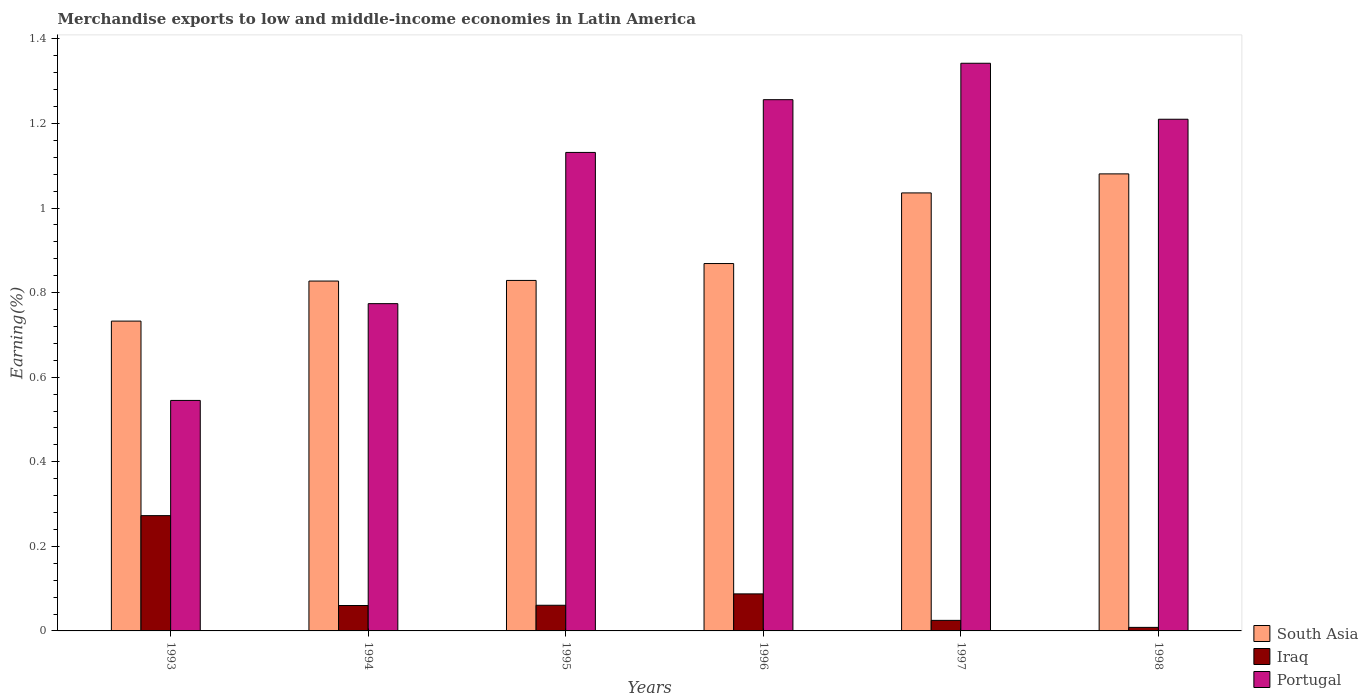How many bars are there on the 4th tick from the right?
Your answer should be very brief. 3. In how many cases, is the number of bars for a given year not equal to the number of legend labels?
Provide a short and direct response. 0. What is the percentage of amount earned from merchandise exports in Portugal in 1997?
Keep it short and to the point. 1.34. Across all years, what is the maximum percentage of amount earned from merchandise exports in Portugal?
Your response must be concise. 1.34. Across all years, what is the minimum percentage of amount earned from merchandise exports in South Asia?
Your answer should be very brief. 0.73. In which year was the percentage of amount earned from merchandise exports in Portugal minimum?
Your answer should be very brief. 1993. What is the total percentage of amount earned from merchandise exports in Portugal in the graph?
Offer a terse response. 6.26. What is the difference between the percentage of amount earned from merchandise exports in Portugal in 1994 and that in 1997?
Your answer should be compact. -0.57. What is the difference between the percentage of amount earned from merchandise exports in Iraq in 1993 and the percentage of amount earned from merchandise exports in South Asia in 1998?
Your answer should be very brief. -0.81. What is the average percentage of amount earned from merchandise exports in Iraq per year?
Your response must be concise. 0.09. In the year 1997, what is the difference between the percentage of amount earned from merchandise exports in Portugal and percentage of amount earned from merchandise exports in South Asia?
Make the answer very short. 0.31. What is the ratio of the percentage of amount earned from merchandise exports in South Asia in 1993 to that in 1995?
Your answer should be compact. 0.88. Is the percentage of amount earned from merchandise exports in South Asia in 1993 less than that in 1997?
Give a very brief answer. Yes. Is the difference between the percentage of amount earned from merchandise exports in Portugal in 1994 and 1997 greater than the difference between the percentage of amount earned from merchandise exports in South Asia in 1994 and 1997?
Make the answer very short. No. What is the difference between the highest and the second highest percentage of amount earned from merchandise exports in Iraq?
Make the answer very short. 0.19. What is the difference between the highest and the lowest percentage of amount earned from merchandise exports in Iraq?
Make the answer very short. 0.26. In how many years, is the percentage of amount earned from merchandise exports in Portugal greater than the average percentage of amount earned from merchandise exports in Portugal taken over all years?
Your answer should be very brief. 4. Is the sum of the percentage of amount earned from merchandise exports in Portugal in 1993 and 1998 greater than the maximum percentage of amount earned from merchandise exports in Iraq across all years?
Give a very brief answer. Yes. What does the 1st bar from the left in 1994 represents?
Your answer should be compact. South Asia. How many bars are there?
Your answer should be very brief. 18. Does the graph contain any zero values?
Your response must be concise. No. Does the graph contain grids?
Offer a very short reply. No. How many legend labels are there?
Provide a succinct answer. 3. What is the title of the graph?
Offer a terse response. Merchandise exports to low and middle-income economies in Latin America. Does "Sao Tome and Principe" appear as one of the legend labels in the graph?
Ensure brevity in your answer.  No. What is the label or title of the X-axis?
Ensure brevity in your answer.  Years. What is the label or title of the Y-axis?
Your answer should be very brief. Earning(%). What is the Earning(%) of South Asia in 1993?
Offer a very short reply. 0.73. What is the Earning(%) in Iraq in 1993?
Provide a succinct answer. 0.27. What is the Earning(%) in Portugal in 1993?
Keep it short and to the point. 0.55. What is the Earning(%) of South Asia in 1994?
Ensure brevity in your answer.  0.83. What is the Earning(%) of Iraq in 1994?
Make the answer very short. 0.06. What is the Earning(%) in Portugal in 1994?
Provide a succinct answer. 0.77. What is the Earning(%) of South Asia in 1995?
Offer a very short reply. 0.83. What is the Earning(%) in Iraq in 1995?
Make the answer very short. 0.06. What is the Earning(%) in Portugal in 1995?
Your answer should be very brief. 1.13. What is the Earning(%) of South Asia in 1996?
Give a very brief answer. 0.87. What is the Earning(%) in Iraq in 1996?
Make the answer very short. 0.09. What is the Earning(%) in Portugal in 1996?
Provide a short and direct response. 1.26. What is the Earning(%) in South Asia in 1997?
Keep it short and to the point. 1.04. What is the Earning(%) in Iraq in 1997?
Offer a very short reply. 0.02. What is the Earning(%) of Portugal in 1997?
Ensure brevity in your answer.  1.34. What is the Earning(%) of South Asia in 1998?
Offer a very short reply. 1.08. What is the Earning(%) of Iraq in 1998?
Your response must be concise. 0.01. What is the Earning(%) in Portugal in 1998?
Make the answer very short. 1.21. Across all years, what is the maximum Earning(%) of South Asia?
Provide a succinct answer. 1.08. Across all years, what is the maximum Earning(%) in Iraq?
Make the answer very short. 0.27. Across all years, what is the maximum Earning(%) in Portugal?
Provide a short and direct response. 1.34. Across all years, what is the minimum Earning(%) of South Asia?
Ensure brevity in your answer.  0.73. Across all years, what is the minimum Earning(%) in Iraq?
Offer a very short reply. 0.01. Across all years, what is the minimum Earning(%) in Portugal?
Keep it short and to the point. 0.55. What is the total Earning(%) of South Asia in the graph?
Your response must be concise. 5.37. What is the total Earning(%) in Iraq in the graph?
Offer a very short reply. 0.51. What is the total Earning(%) in Portugal in the graph?
Ensure brevity in your answer.  6.26. What is the difference between the Earning(%) in South Asia in 1993 and that in 1994?
Provide a succinct answer. -0.09. What is the difference between the Earning(%) in Iraq in 1993 and that in 1994?
Provide a succinct answer. 0.21. What is the difference between the Earning(%) in Portugal in 1993 and that in 1994?
Make the answer very short. -0.23. What is the difference between the Earning(%) of South Asia in 1993 and that in 1995?
Offer a terse response. -0.1. What is the difference between the Earning(%) of Iraq in 1993 and that in 1995?
Your response must be concise. 0.21. What is the difference between the Earning(%) in Portugal in 1993 and that in 1995?
Give a very brief answer. -0.59. What is the difference between the Earning(%) in South Asia in 1993 and that in 1996?
Give a very brief answer. -0.14. What is the difference between the Earning(%) of Iraq in 1993 and that in 1996?
Your answer should be very brief. 0.18. What is the difference between the Earning(%) of Portugal in 1993 and that in 1996?
Offer a very short reply. -0.71. What is the difference between the Earning(%) of South Asia in 1993 and that in 1997?
Make the answer very short. -0.3. What is the difference between the Earning(%) of Iraq in 1993 and that in 1997?
Your answer should be compact. 0.25. What is the difference between the Earning(%) in Portugal in 1993 and that in 1997?
Offer a terse response. -0.8. What is the difference between the Earning(%) of South Asia in 1993 and that in 1998?
Offer a very short reply. -0.35. What is the difference between the Earning(%) in Iraq in 1993 and that in 1998?
Your answer should be very brief. 0.26. What is the difference between the Earning(%) of Portugal in 1993 and that in 1998?
Keep it short and to the point. -0.66. What is the difference between the Earning(%) in South Asia in 1994 and that in 1995?
Provide a short and direct response. -0. What is the difference between the Earning(%) in Iraq in 1994 and that in 1995?
Provide a short and direct response. -0. What is the difference between the Earning(%) in Portugal in 1994 and that in 1995?
Offer a very short reply. -0.36. What is the difference between the Earning(%) in South Asia in 1994 and that in 1996?
Ensure brevity in your answer.  -0.04. What is the difference between the Earning(%) of Iraq in 1994 and that in 1996?
Make the answer very short. -0.03. What is the difference between the Earning(%) of Portugal in 1994 and that in 1996?
Your response must be concise. -0.48. What is the difference between the Earning(%) in South Asia in 1994 and that in 1997?
Provide a short and direct response. -0.21. What is the difference between the Earning(%) of Iraq in 1994 and that in 1997?
Provide a succinct answer. 0.04. What is the difference between the Earning(%) in Portugal in 1994 and that in 1997?
Offer a very short reply. -0.57. What is the difference between the Earning(%) in South Asia in 1994 and that in 1998?
Provide a short and direct response. -0.25. What is the difference between the Earning(%) in Iraq in 1994 and that in 1998?
Offer a terse response. 0.05. What is the difference between the Earning(%) of Portugal in 1994 and that in 1998?
Provide a short and direct response. -0.44. What is the difference between the Earning(%) in South Asia in 1995 and that in 1996?
Make the answer very short. -0.04. What is the difference between the Earning(%) in Iraq in 1995 and that in 1996?
Offer a very short reply. -0.03. What is the difference between the Earning(%) of Portugal in 1995 and that in 1996?
Ensure brevity in your answer.  -0.12. What is the difference between the Earning(%) of South Asia in 1995 and that in 1997?
Your answer should be very brief. -0.21. What is the difference between the Earning(%) in Iraq in 1995 and that in 1997?
Your answer should be very brief. 0.04. What is the difference between the Earning(%) of Portugal in 1995 and that in 1997?
Your response must be concise. -0.21. What is the difference between the Earning(%) of South Asia in 1995 and that in 1998?
Your answer should be very brief. -0.25. What is the difference between the Earning(%) in Iraq in 1995 and that in 1998?
Give a very brief answer. 0.05. What is the difference between the Earning(%) of Portugal in 1995 and that in 1998?
Ensure brevity in your answer.  -0.08. What is the difference between the Earning(%) in South Asia in 1996 and that in 1997?
Your response must be concise. -0.17. What is the difference between the Earning(%) of Iraq in 1996 and that in 1997?
Your response must be concise. 0.06. What is the difference between the Earning(%) of Portugal in 1996 and that in 1997?
Provide a short and direct response. -0.09. What is the difference between the Earning(%) in South Asia in 1996 and that in 1998?
Offer a terse response. -0.21. What is the difference between the Earning(%) of Iraq in 1996 and that in 1998?
Offer a very short reply. 0.08. What is the difference between the Earning(%) in Portugal in 1996 and that in 1998?
Your answer should be compact. 0.05. What is the difference between the Earning(%) in South Asia in 1997 and that in 1998?
Offer a very short reply. -0.04. What is the difference between the Earning(%) of Iraq in 1997 and that in 1998?
Make the answer very short. 0.02. What is the difference between the Earning(%) in Portugal in 1997 and that in 1998?
Your answer should be very brief. 0.13. What is the difference between the Earning(%) of South Asia in 1993 and the Earning(%) of Iraq in 1994?
Give a very brief answer. 0.67. What is the difference between the Earning(%) in South Asia in 1993 and the Earning(%) in Portugal in 1994?
Offer a terse response. -0.04. What is the difference between the Earning(%) of Iraq in 1993 and the Earning(%) of Portugal in 1994?
Give a very brief answer. -0.5. What is the difference between the Earning(%) of South Asia in 1993 and the Earning(%) of Iraq in 1995?
Your answer should be compact. 0.67. What is the difference between the Earning(%) of South Asia in 1993 and the Earning(%) of Portugal in 1995?
Give a very brief answer. -0.4. What is the difference between the Earning(%) of Iraq in 1993 and the Earning(%) of Portugal in 1995?
Your answer should be compact. -0.86. What is the difference between the Earning(%) in South Asia in 1993 and the Earning(%) in Iraq in 1996?
Provide a succinct answer. 0.65. What is the difference between the Earning(%) of South Asia in 1993 and the Earning(%) of Portugal in 1996?
Offer a terse response. -0.52. What is the difference between the Earning(%) in Iraq in 1993 and the Earning(%) in Portugal in 1996?
Keep it short and to the point. -0.98. What is the difference between the Earning(%) of South Asia in 1993 and the Earning(%) of Iraq in 1997?
Offer a terse response. 0.71. What is the difference between the Earning(%) of South Asia in 1993 and the Earning(%) of Portugal in 1997?
Your answer should be compact. -0.61. What is the difference between the Earning(%) of Iraq in 1993 and the Earning(%) of Portugal in 1997?
Provide a succinct answer. -1.07. What is the difference between the Earning(%) in South Asia in 1993 and the Earning(%) in Iraq in 1998?
Make the answer very short. 0.72. What is the difference between the Earning(%) in South Asia in 1993 and the Earning(%) in Portugal in 1998?
Your answer should be very brief. -0.48. What is the difference between the Earning(%) of Iraq in 1993 and the Earning(%) of Portugal in 1998?
Your answer should be compact. -0.94. What is the difference between the Earning(%) in South Asia in 1994 and the Earning(%) in Iraq in 1995?
Keep it short and to the point. 0.77. What is the difference between the Earning(%) in South Asia in 1994 and the Earning(%) in Portugal in 1995?
Make the answer very short. -0.3. What is the difference between the Earning(%) in Iraq in 1994 and the Earning(%) in Portugal in 1995?
Offer a very short reply. -1.07. What is the difference between the Earning(%) in South Asia in 1994 and the Earning(%) in Iraq in 1996?
Give a very brief answer. 0.74. What is the difference between the Earning(%) in South Asia in 1994 and the Earning(%) in Portugal in 1996?
Make the answer very short. -0.43. What is the difference between the Earning(%) of Iraq in 1994 and the Earning(%) of Portugal in 1996?
Ensure brevity in your answer.  -1.2. What is the difference between the Earning(%) in South Asia in 1994 and the Earning(%) in Iraq in 1997?
Offer a terse response. 0.8. What is the difference between the Earning(%) in South Asia in 1994 and the Earning(%) in Portugal in 1997?
Provide a succinct answer. -0.52. What is the difference between the Earning(%) of Iraq in 1994 and the Earning(%) of Portugal in 1997?
Offer a very short reply. -1.28. What is the difference between the Earning(%) of South Asia in 1994 and the Earning(%) of Iraq in 1998?
Ensure brevity in your answer.  0.82. What is the difference between the Earning(%) of South Asia in 1994 and the Earning(%) of Portugal in 1998?
Provide a short and direct response. -0.38. What is the difference between the Earning(%) in Iraq in 1994 and the Earning(%) in Portugal in 1998?
Your answer should be very brief. -1.15. What is the difference between the Earning(%) of South Asia in 1995 and the Earning(%) of Iraq in 1996?
Your response must be concise. 0.74. What is the difference between the Earning(%) of South Asia in 1995 and the Earning(%) of Portugal in 1996?
Make the answer very short. -0.43. What is the difference between the Earning(%) of Iraq in 1995 and the Earning(%) of Portugal in 1996?
Ensure brevity in your answer.  -1.2. What is the difference between the Earning(%) of South Asia in 1995 and the Earning(%) of Iraq in 1997?
Ensure brevity in your answer.  0.8. What is the difference between the Earning(%) in South Asia in 1995 and the Earning(%) in Portugal in 1997?
Provide a short and direct response. -0.51. What is the difference between the Earning(%) in Iraq in 1995 and the Earning(%) in Portugal in 1997?
Your response must be concise. -1.28. What is the difference between the Earning(%) of South Asia in 1995 and the Earning(%) of Iraq in 1998?
Your answer should be compact. 0.82. What is the difference between the Earning(%) of South Asia in 1995 and the Earning(%) of Portugal in 1998?
Your response must be concise. -0.38. What is the difference between the Earning(%) in Iraq in 1995 and the Earning(%) in Portugal in 1998?
Provide a short and direct response. -1.15. What is the difference between the Earning(%) in South Asia in 1996 and the Earning(%) in Iraq in 1997?
Your answer should be very brief. 0.84. What is the difference between the Earning(%) of South Asia in 1996 and the Earning(%) of Portugal in 1997?
Give a very brief answer. -0.47. What is the difference between the Earning(%) of Iraq in 1996 and the Earning(%) of Portugal in 1997?
Your answer should be very brief. -1.25. What is the difference between the Earning(%) of South Asia in 1996 and the Earning(%) of Iraq in 1998?
Provide a succinct answer. 0.86. What is the difference between the Earning(%) in South Asia in 1996 and the Earning(%) in Portugal in 1998?
Offer a very short reply. -0.34. What is the difference between the Earning(%) of Iraq in 1996 and the Earning(%) of Portugal in 1998?
Make the answer very short. -1.12. What is the difference between the Earning(%) in South Asia in 1997 and the Earning(%) in Iraq in 1998?
Your answer should be very brief. 1.03. What is the difference between the Earning(%) of South Asia in 1997 and the Earning(%) of Portugal in 1998?
Your response must be concise. -0.17. What is the difference between the Earning(%) in Iraq in 1997 and the Earning(%) in Portugal in 1998?
Your answer should be compact. -1.19. What is the average Earning(%) in South Asia per year?
Offer a very short reply. 0.9. What is the average Earning(%) in Iraq per year?
Make the answer very short. 0.09. What is the average Earning(%) in Portugal per year?
Your answer should be very brief. 1.04. In the year 1993, what is the difference between the Earning(%) of South Asia and Earning(%) of Iraq?
Your answer should be compact. 0.46. In the year 1993, what is the difference between the Earning(%) in South Asia and Earning(%) in Portugal?
Give a very brief answer. 0.19. In the year 1993, what is the difference between the Earning(%) of Iraq and Earning(%) of Portugal?
Keep it short and to the point. -0.27. In the year 1994, what is the difference between the Earning(%) in South Asia and Earning(%) in Iraq?
Your response must be concise. 0.77. In the year 1994, what is the difference between the Earning(%) in South Asia and Earning(%) in Portugal?
Your response must be concise. 0.05. In the year 1994, what is the difference between the Earning(%) in Iraq and Earning(%) in Portugal?
Your response must be concise. -0.71. In the year 1995, what is the difference between the Earning(%) in South Asia and Earning(%) in Iraq?
Give a very brief answer. 0.77. In the year 1995, what is the difference between the Earning(%) in South Asia and Earning(%) in Portugal?
Give a very brief answer. -0.3. In the year 1995, what is the difference between the Earning(%) of Iraq and Earning(%) of Portugal?
Make the answer very short. -1.07. In the year 1996, what is the difference between the Earning(%) in South Asia and Earning(%) in Iraq?
Ensure brevity in your answer.  0.78. In the year 1996, what is the difference between the Earning(%) in South Asia and Earning(%) in Portugal?
Give a very brief answer. -0.39. In the year 1996, what is the difference between the Earning(%) in Iraq and Earning(%) in Portugal?
Your answer should be very brief. -1.17. In the year 1997, what is the difference between the Earning(%) in South Asia and Earning(%) in Iraq?
Your answer should be compact. 1.01. In the year 1997, what is the difference between the Earning(%) of South Asia and Earning(%) of Portugal?
Offer a terse response. -0.31. In the year 1997, what is the difference between the Earning(%) of Iraq and Earning(%) of Portugal?
Make the answer very short. -1.32. In the year 1998, what is the difference between the Earning(%) in South Asia and Earning(%) in Iraq?
Ensure brevity in your answer.  1.07. In the year 1998, what is the difference between the Earning(%) in South Asia and Earning(%) in Portugal?
Keep it short and to the point. -0.13. In the year 1998, what is the difference between the Earning(%) in Iraq and Earning(%) in Portugal?
Offer a terse response. -1.2. What is the ratio of the Earning(%) of South Asia in 1993 to that in 1994?
Offer a terse response. 0.89. What is the ratio of the Earning(%) in Iraq in 1993 to that in 1994?
Your answer should be very brief. 4.54. What is the ratio of the Earning(%) in Portugal in 1993 to that in 1994?
Give a very brief answer. 0.7. What is the ratio of the Earning(%) in South Asia in 1993 to that in 1995?
Your answer should be compact. 0.88. What is the ratio of the Earning(%) of Iraq in 1993 to that in 1995?
Offer a terse response. 4.49. What is the ratio of the Earning(%) of Portugal in 1993 to that in 1995?
Provide a succinct answer. 0.48. What is the ratio of the Earning(%) in South Asia in 1993 to that in 1996?
Offer a very short reply. 0.84. What is the ratio of the Earning(%) in Iraq in 1993 to that in 1996?
Keep it short and to the point. 3.11. What is the ratio of the Earning(%) of Portugal in 1993 to that in 1996?
Your answer should be compact. 0.43. What is the ratio of the Earning(%) in South Asia in 1993 to that in 1997?
Offer a very short reply. 0.71. What is the ratio of the Earning(%) of Iraq in 1993 to that in 1997?
Your response must be concise. 10.92. What is the ratio of the Earning(%) in Portugal in 1993 to that in 1997?
Ensure brevity in your answer.  0.41. What is the ratio of the Earning(%) of South Asia in 1993 to that in 1998?
Provide a succinct answer. 0.68. What is the ratio of the Earning(%) in Iraq in 1993 to that in 1998?
Ensure brevity in your answer.  32.65. What is the ratio of the Earning(%) of Portugal in 1993 to that in 1998?
Your response must be concise. 0.45. What is the ratio of the Earning(%) of Iraq in 1994 to that in 1995?
Your response must be concise. 0.99. What is the ratio of the Earning(%) in Portugal in 1994 to that in 1995?
Provide a succinct answer. 0.68. What is the ratio of the Earning(%) in South Asia in 1994 to that in 1996?
Ensure brevity in your answer.  0.95. What is the ratio of the Earning(%) of Iraq in 1994 to that in 1996?
Your answer should be compact. 0.69. What is the ratio of the Earning(%) in Portugal in 1994 to that in 1996?
Offer a terse response. 0.62. What is the ratio of the Earning(%) in South Asia in 1994 to that in 1997?
Keep it short and to the point. 0.8. What is the ratio of the Earning(%) in Iraq in 1994 to that in 1997?
Your response must be concise. 2.41. What is the ratio of the Earning(%) of Portugal in 1994 to that in 1997?
Keep it short and to the point. 0.58. What is the ratio of the Earning(%) in South Asia in 1994 to that in 1998?
Provide a succinct answer. 0.77. What is the ratio of the Earning(%) of Iraq in 1994 to that in 1998?
Your answer should be compact. 7.2. What is the ratio of the Earning(%) of Portugal in 1994 to that in 1998?
Keep it short and to the point. 0.64. What is the ratio of the Earning(%) of South Asia in 1995 to that in 1996?
Ensure brevity in your answer.  0.95. What is the ratio of the Earning(%) of Iraq in 1995 to that in 1996?
Offer a terse response. 0.69. What is the ratio of the Earning(%) in Portugal in 1995 to that in 1996?
Ensure brevity in your answer.  0.9. What is the ratio of the Earning(%) of South Asia in 1995 to that in 1997?
Your response must be concise. 0.8. What is the ratio of the Earning(%) in Iraq in 1995 to that in 1997?
Your answer should be very brief. 2.43. What is the ratio of the Earning(%) of Portugal in 1995 to that in 1997?
Make the answer very short. 0.84. What is the ratio of the Earning(%) of South Asia in 1995 to that in 1998?
Ensure brevity in your answer.  0.77. What is the ratio of the Earning(%) of Iraq in 1995 to that in 1998?
Provide a succinct answer. 7.27. What is the ratio of the Earning(%) of Portugal in 1995 to that in 1998?
Your response must be concise. 0.94. What is the ratio of the Earning(%) of South Asia in 1996 to that in 1997?
Offer a very short reply. 0.84. What is the ratio of the Earning(%) in Iraq in 1996 to that in 1997?
Provide a succinct answer. 3.51. What is the ratio of the Earning(%) in Portugal in 1996 to that in 1997?
Provide a succinct answer. 0.94. What is the ratio of the Earning(%) of South Asia in 1996 to that in 1998?
Your response must be concise. 0.8. What is the ratio of the Earning(%) of Iraq in 1996 to that in 1998?
Provide a short and direct response. 10.49. What is the ratio of the Earning(%) of Portugal in 1996 to that in 1998?
Provide a succinct answer. 1.04. What is the ratio of the Earning(%) of South Asia in 1997 to that in 1998?
Provide a succinct answer. 0.96. What is the ratio of the Earning(%) of Iraq in 1997 to that in 1998?
Your response must be concise. 2.99. What is the ratio of the Earning(%) of Portugal in 1997 to that in 1998?
Your answer should be compact. 1.11. What is the difference between the highest and the second highest Earning(%) of South Asia?
Keep it short and to the point. 0.04. What is the difference between the highest and the second highest Earning(%) in Iraq?
Give a very brief answer. 0.18. What is the difference between the highest and the second highest Earning(%) in Portugal?
Your response must be concise. 0.09. What is the difference between the highest and the lowest Earning(%) in South Asia?
Provide a short and direct response. 0.35. What is the difference between the highest and the lowest Earning(%) of Iraq?
Give a very brief answer. 0.26. What is the difference between the highest and the lowest Earning(%) in Portugal?
Make the answer very short. 0.8. 